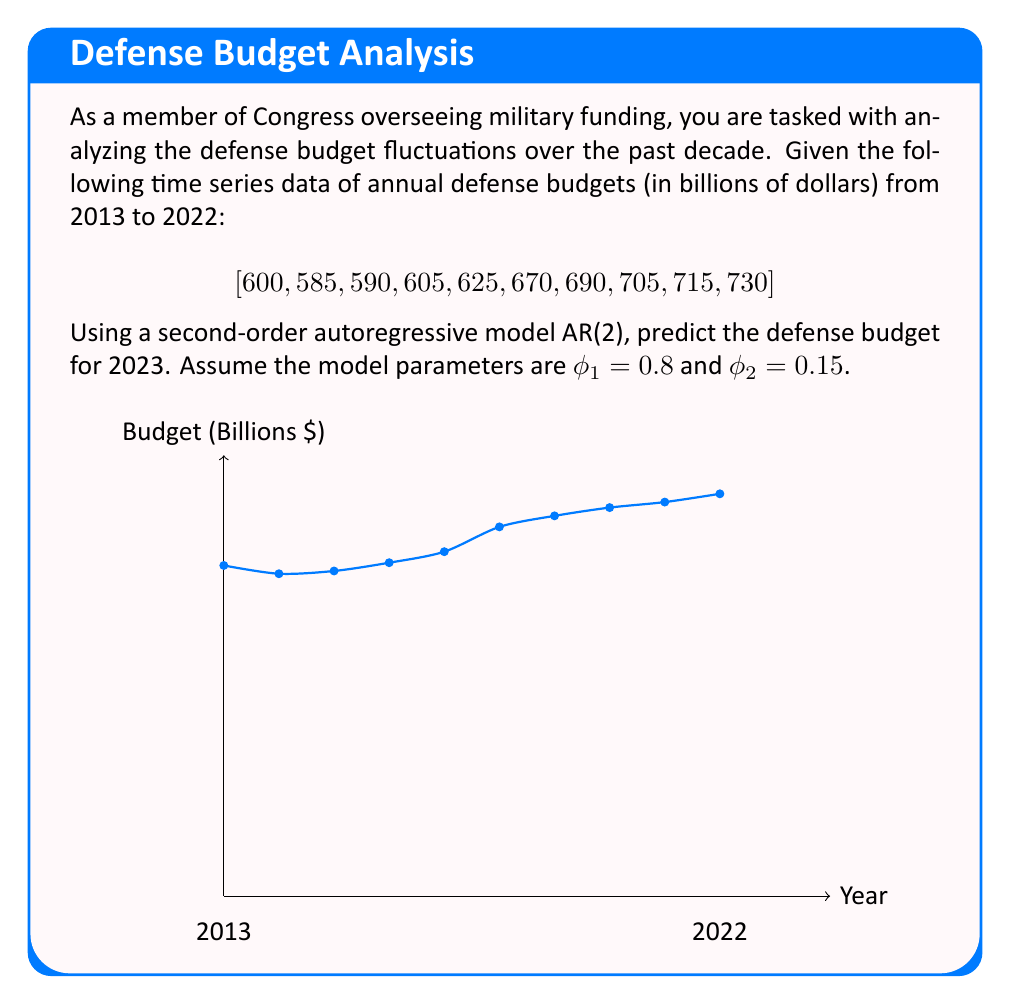Could you help me with this problem? To predict the defense budget for 2023 using an AR(2) model, we'll follow these steps:

1) The general form of an AR(2) model is:

   $$X_t = c + \phi_1 X_{t-1} + \phi_2 X_{t-2} + \epsilon_t$$

   where $c$ is a constant, $\phi_1$ and $\phi_2$ are the model parameters, and $\epsilon_t$ is white noise.

2) We're given $\phi_1 = 0.8$ and $\phi_2 = 0.15$. We don't need to calculate $c$ or $\epsilon_t$ for this prediction.

3) To predict the 2023 budget (which we'll call $X_{11}$), we need the values for 2022 ($X_{10} = 730$) and 2021 ($X_9 = 715$).

4) Plugging these into our AR(2) equation:

   $$X_{11} = c + 0.8X_{10} + 0.15X_9 + \epsilon_{11}$$

5) Substituting the known values:

   $$X_{11} = c + 0.8(730) + 0.15(715) + \epsilon_{11}$$

6) Simplifying:

   $$X_{11} = c + 584 + 107.25 + \epsilon_{11}$$
   $$X_{11} = 691.25 + c + \epsilon_{11}$$

7) Since we don't have information about $c$ and $\epsilon_{11}$, our best prediction is:

   $$X_{11} \approx 691.25$$

8) Rounding to the nearest billion:

   $$X_{11} \approx 691$$

Thus, the predicted defense budget for 2023 is approximately $691 billion.
Answer: $691 billion 